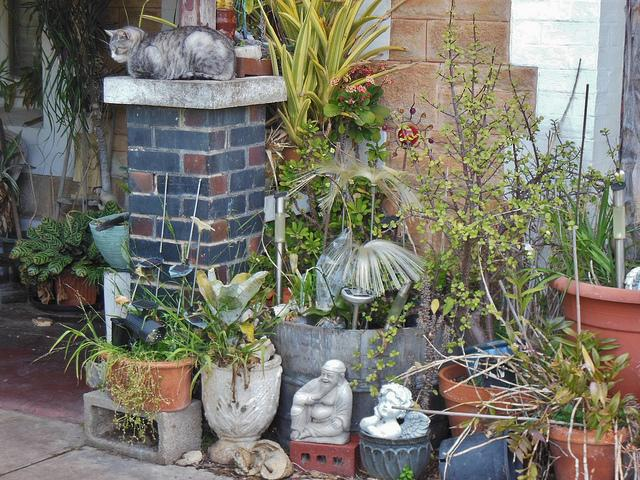What is the little angel in the flower pot called?

Choices:
A) raphael
B) gabriel
C) cherub
D) michael cherub 